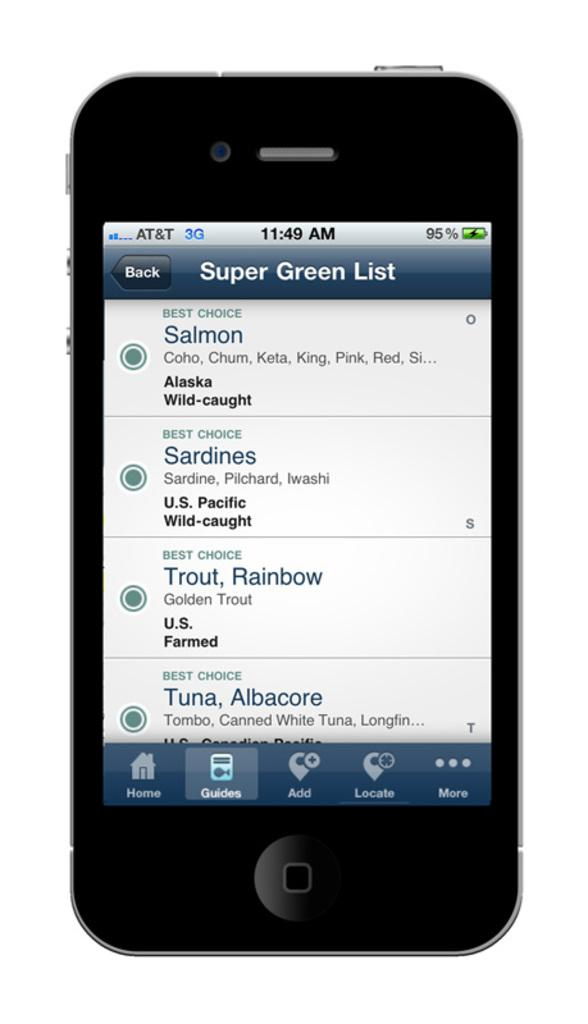<image>
Describe the image concisely. An Apple iPhone is showing a tab that says Super Green List. 